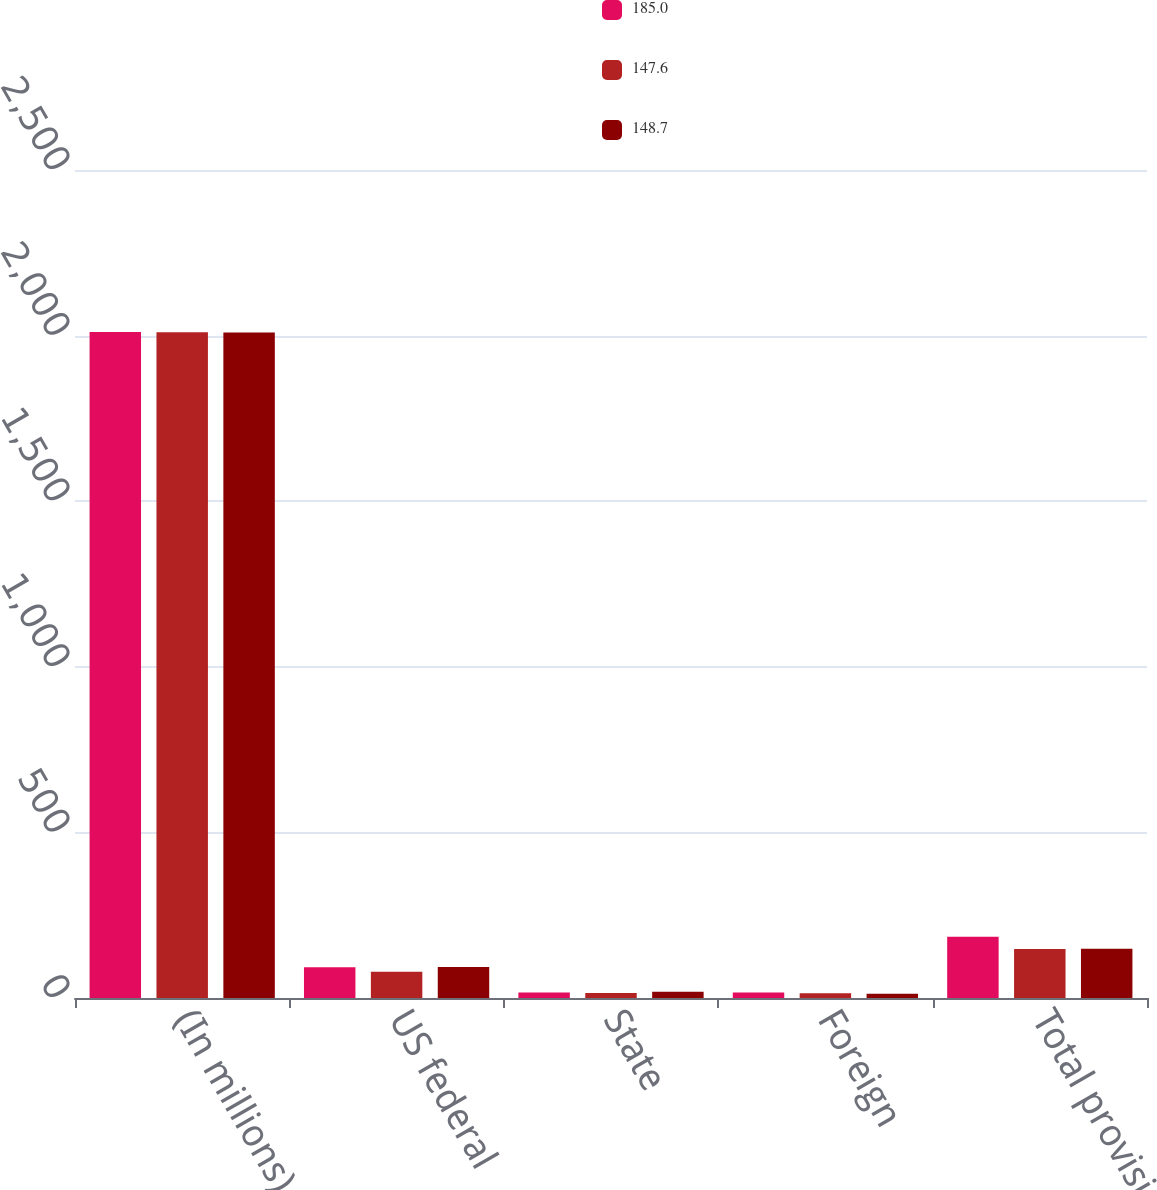Convert chart. <chart><loc_0><loc_0><loc_500><loc_500><stacked_bar_chart><ecel><fcel>(In millions)<fcel>US federal<fcel>State<fcel>Foreign<fcel>Total provision<nl><fcel>185<fcel>2011<fcel>92.7<fcel>16.3<fcel>16.6<fcel>185<nl><fcel>147.6<fcel>2010<fcel>79<fcel>15.4<fcel>14.3<fcel>147.6<nl><fcel>148.7<fcel>2009<fcel>93.8<fcel>18.8<fcel>13<fcel>148.7<nl></chart> 